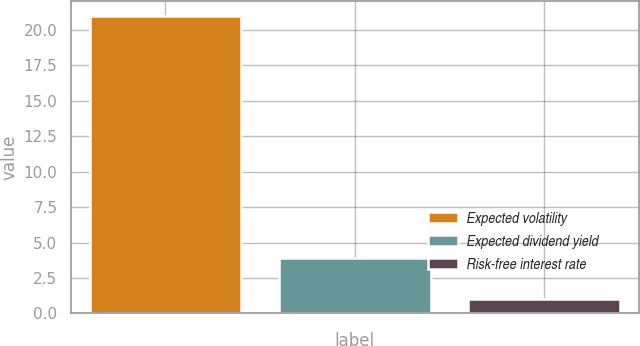Convert chart to OTSL. <chart><loc_0><loc_0><loc_500><loc_500><bar_chart><fcel>Expected volatility<fcel>Expected dividend yield<fcel>Risk-free interest rate<nl><fcel>21<fcel>3.89<fcel>1<nl></chart> 